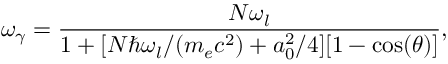<formula> <loc_0><loc_0><loc_500><loc_500>\omega _ { \gamma } = \frac { N \omega _ { l } } { 1 + [ N \hbar { \omega } _ { l } / ( m _ { e } c ^ { 2 } ) + a _ { 0 } ^ { 2 } / 4 ] [ 1 - \cos ( \theta ) ] } ,</formula> 